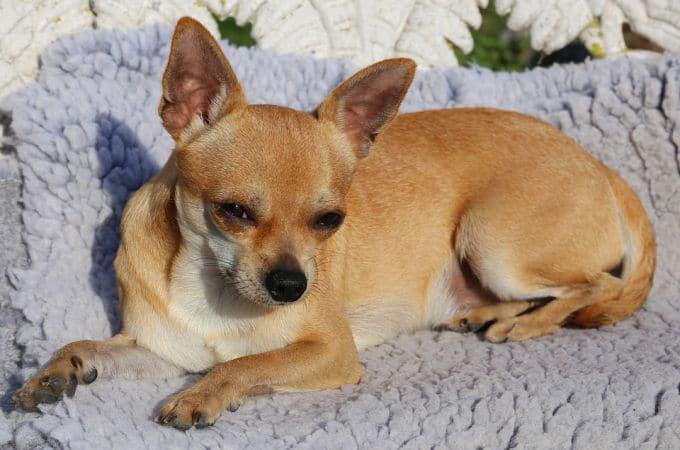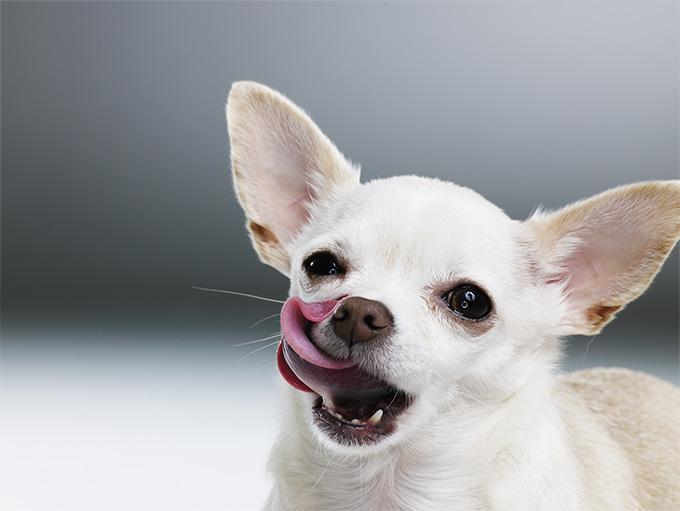The first image is the image on the left, the second image is the image on the right. Given the left and right images, does the statement "There are two chihuahuas with their heads to the right and tails up to the left." hold true? Answer yes or no. No. 